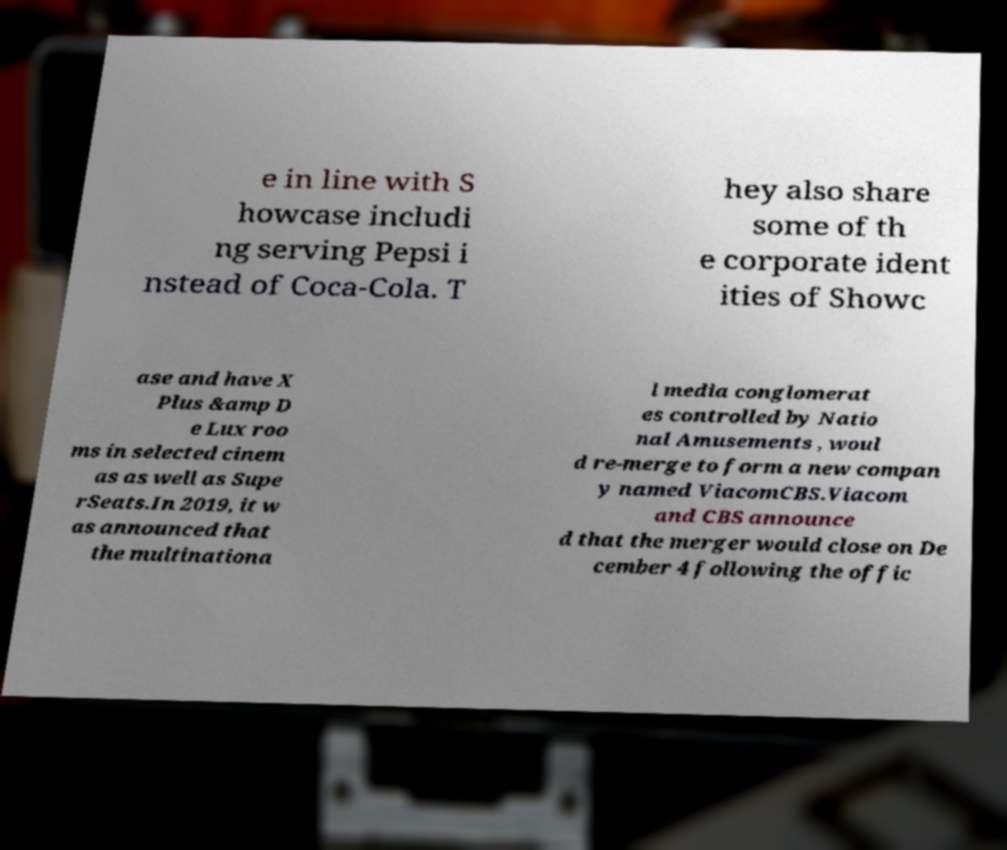Could you assist in decoding the text presented in this image and type it out clearly? e in line with S howcase includi ng serving Pepsi i nstead of Coca-Cola. T hey also share some of th e corporate ident ities of Showc ase and have X Plus &amp D e Lux roo ms in selected cinem as as well as Supe rSeats.In 2019, it w as announced that the multinationa l media conglomerat es controlled by Natio nal Amusements , woul d re-merge to form a new compan y named ViacomCBS.Viacom and CBS announce d that the merger would close on De cember 4 following the offic 